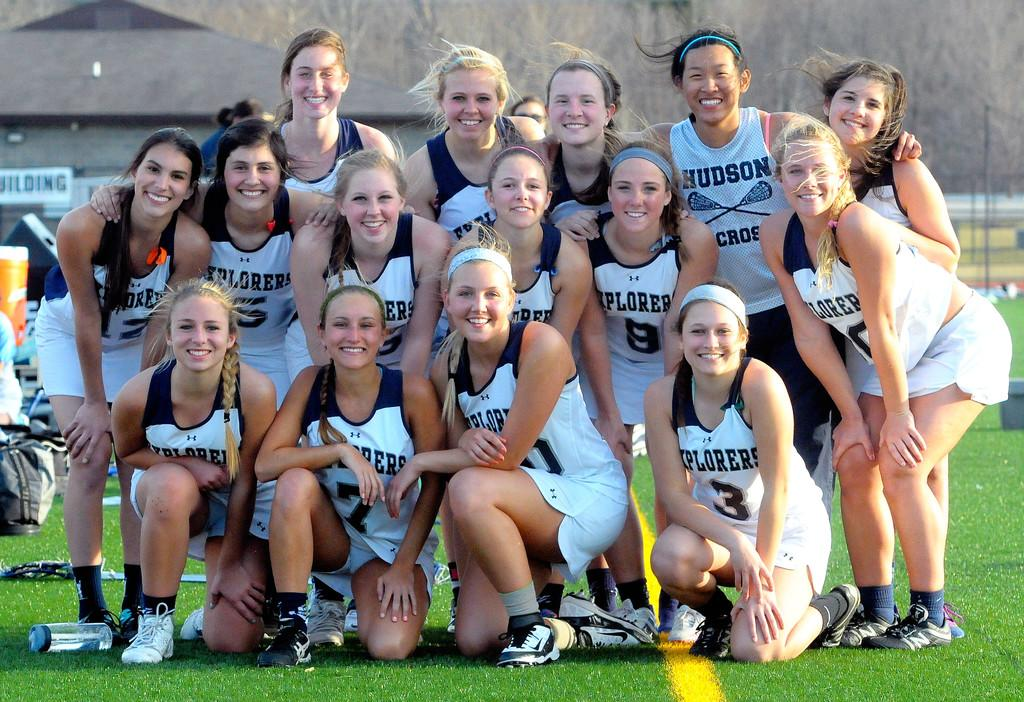Provide a one-sentence caption for the provided image. The girls with the green headband has a shirt that says Hudson on it. 